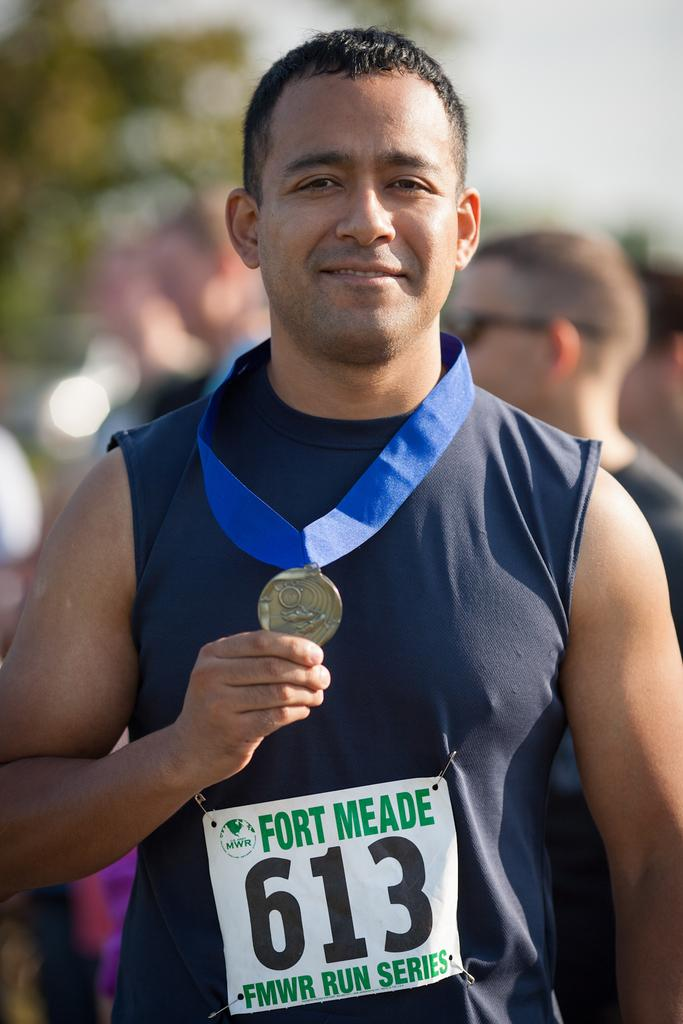<image>
Create a compact narrative representing the image presented. The Ford  Meade athlete shows us his medal which is around his neck. 